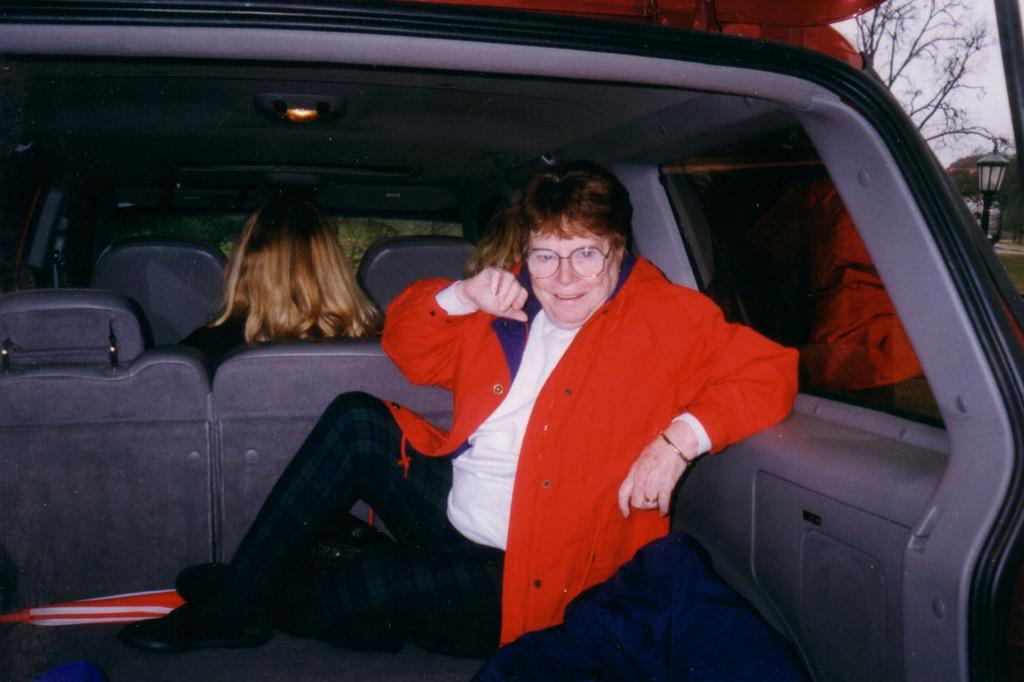How many women are in the image? There are two women in the image. What is one of the women doing in the image? One woman is sitting at the back of a vehicle. What is the expression on the woman's face? The woman is smiling. What can be seen through the windows in the image? There are trees visible through the windows in the image. What is the source of light in the image? There is light in the image, but the specific source is not mentioned. What type of button is the dad wearing in the image? There is no dad present in the image, and therefore no button to describe. What is the best route to take to reach the location shown in the image? The image does not provide enough information to determine the best route to reach the location. 